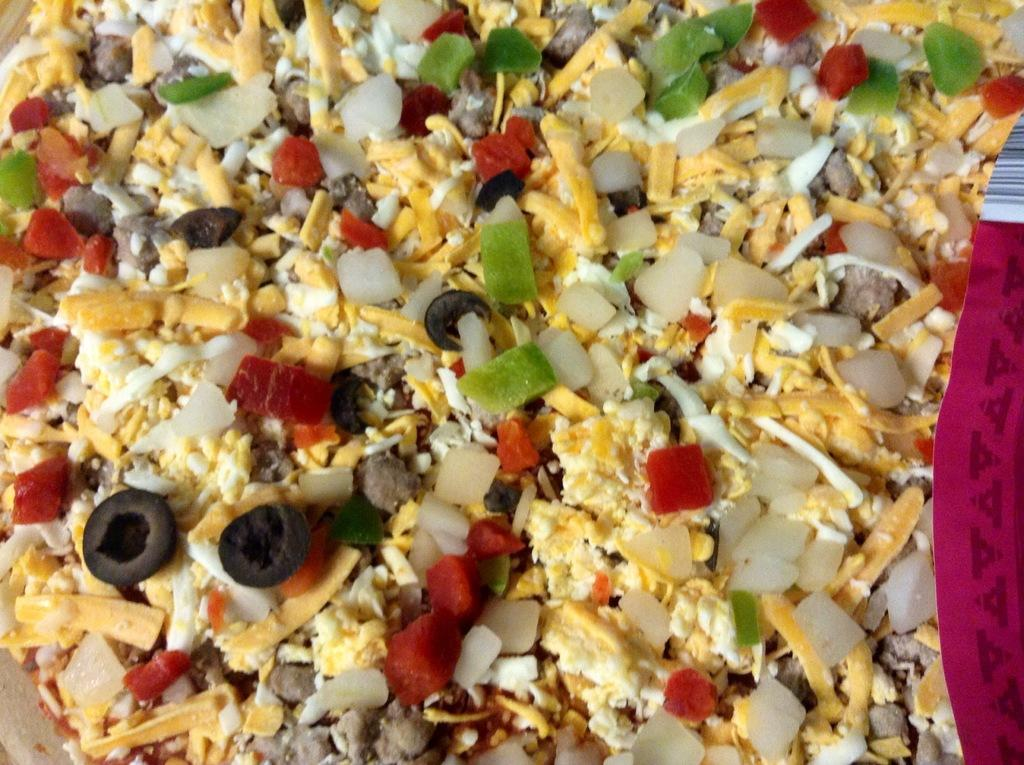What is the main subject of the image? The main subject of the image is a food item. Can you describe the colors present in the food item? The food item includes the colors red, green, brown, white, and yellow. What type of account is associated with the leaf on the sofa in the image? There is no leaf or sofa present in the image; it is a zoomed-in picture of a food item. 